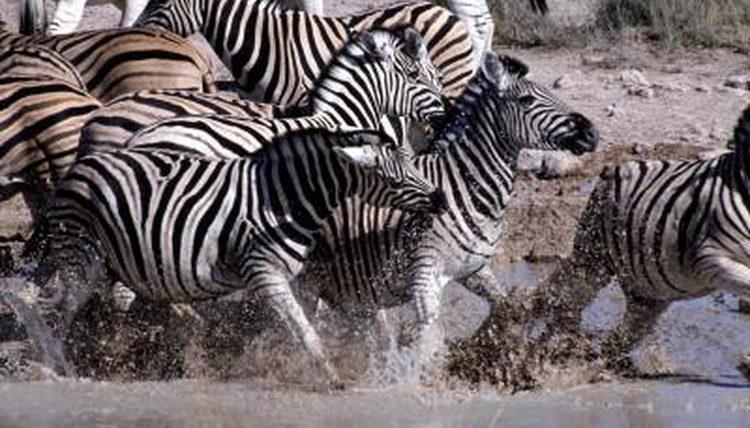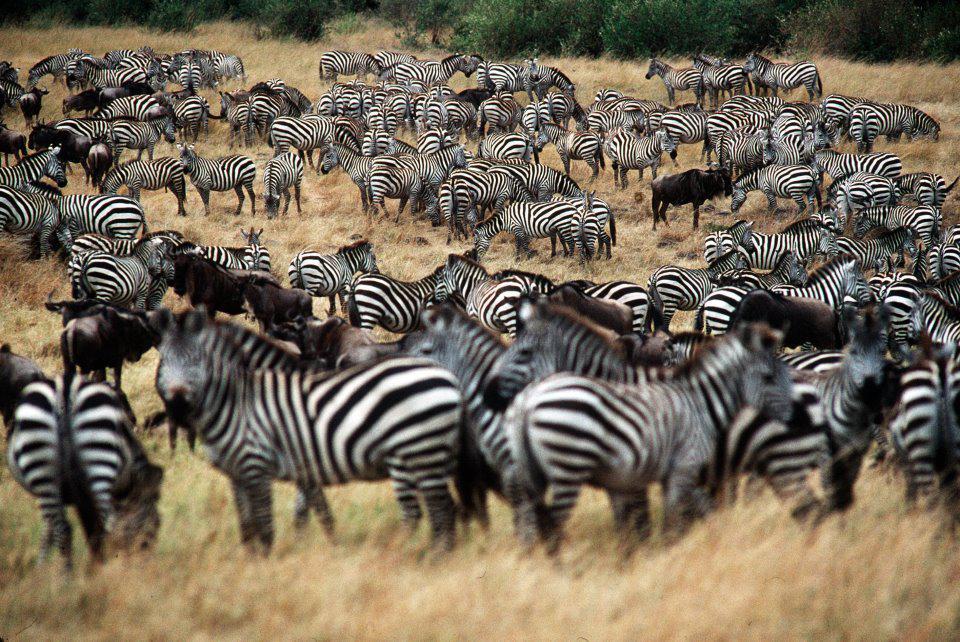The first image is the image on the left, the second image is the image on the right. Considering the images on both sides, is "The left image shows zebras splashing as they run rightward through water, and the image features only zebra-type animals." valid? Answer yes or no. Yes. 